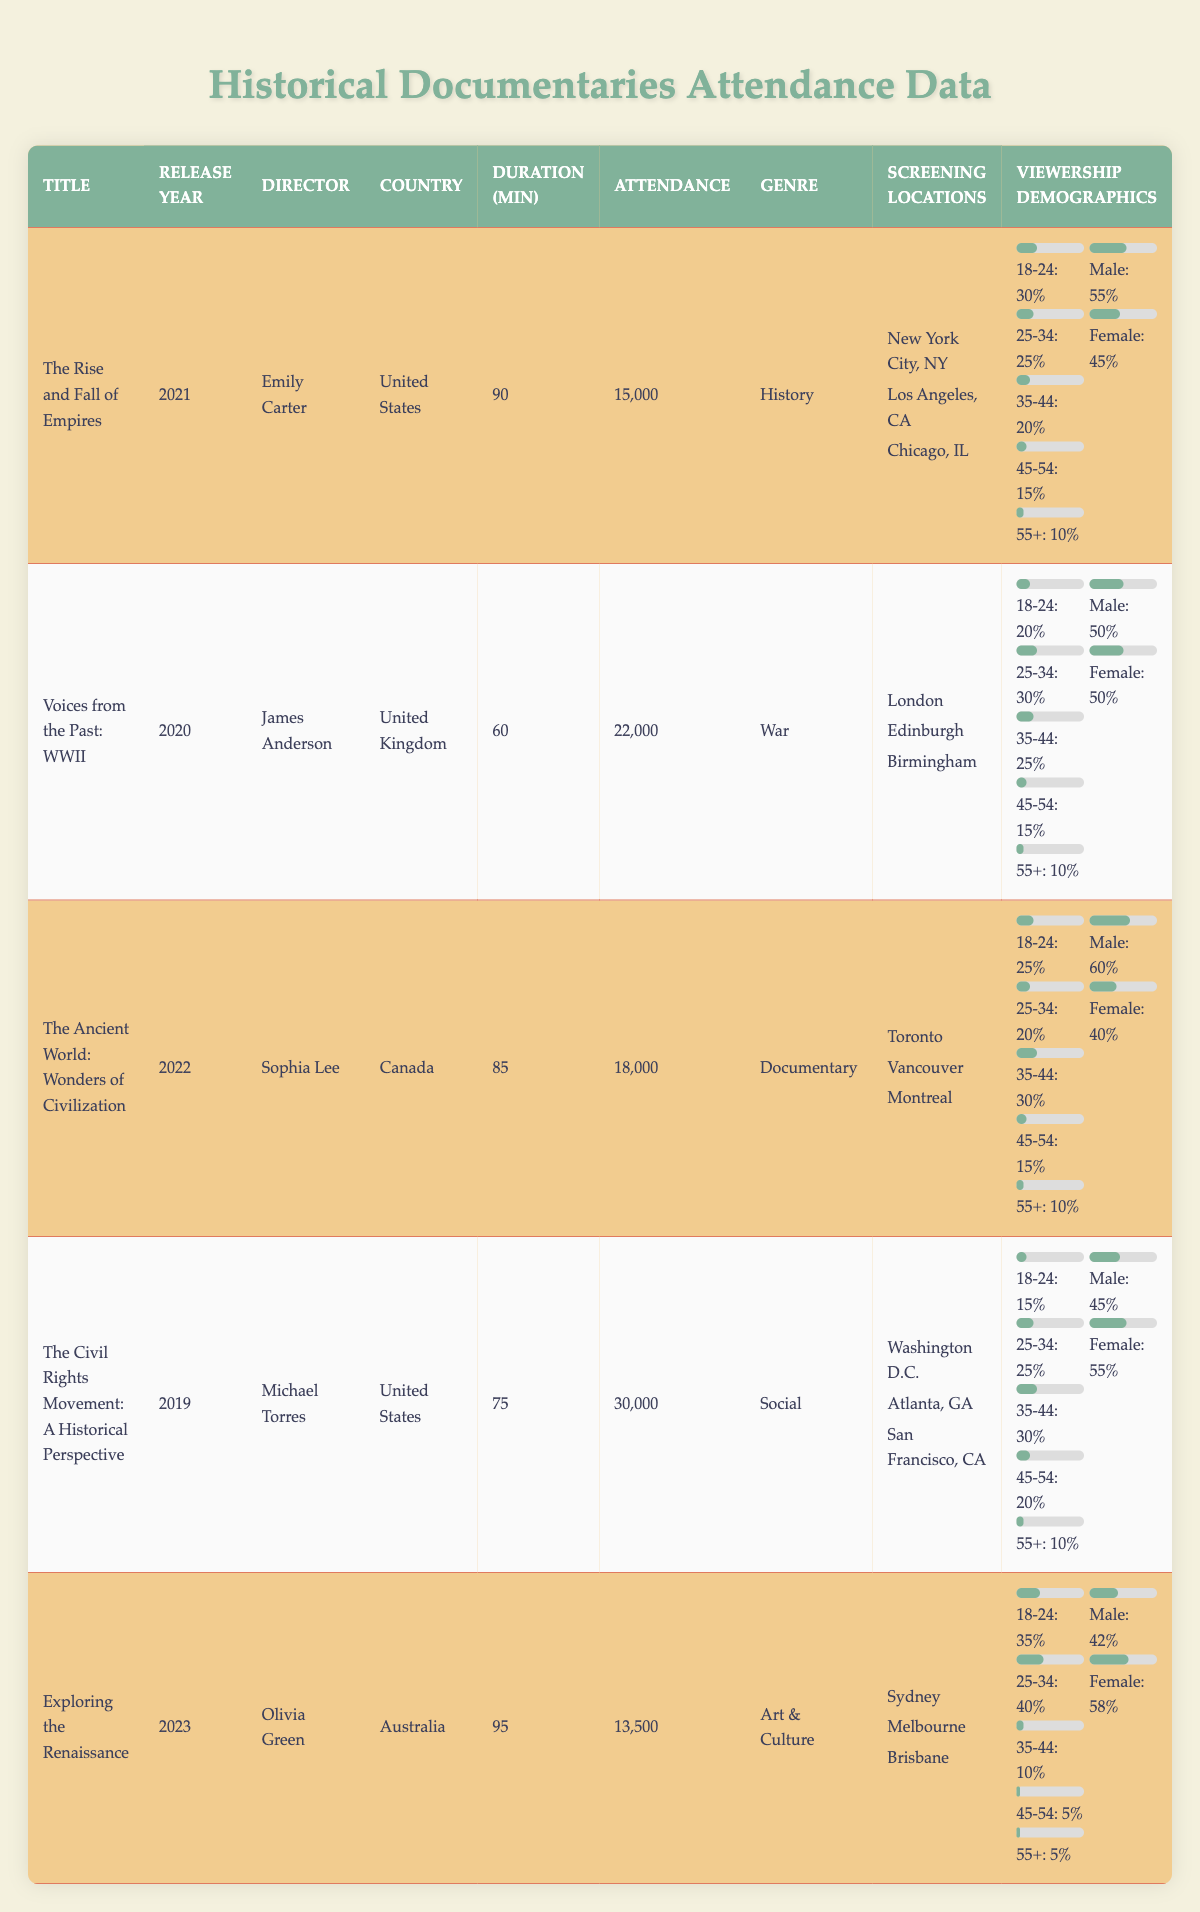What is the attendance for "The Civil Rights Movement: A Historical Perspective"? The attendance value is found directly in the table under the corresponding title. It states that "The Civil Rights Movement: A Historical Perspective" has an attendance of 30,000.
Answer: 30,000 Which historical documentary has the highest attendance? By comparing the attendance figures in the attendance column, "The Civil Rights Movement: A Historical Perspective" has the highest attendance of 30,000, compared to the others.
Answer: The Civil Rights Movement: A Historical Perspective How many minutes long is "Exploring the Renaissance"? The duration for "Exploring the Renaissance" is given directly in the table under the duration column, which states it's 95 minutes long.
Answer: 95 minutes In which country was "The Ancient World: Wonders of Civilization" directed? The table explicitly states that "The Ancient World: Wonders of Civilization" was directed in Canada, which is indicated in the country column.
Answer: Canada What is the age group percentage for the demographic of 35-44 for the documentary "Voices from the Past: WWII"? The age group demographic percentage for 35-44 is listed in the table under the viewership demographics section for that documentary, showing it is 25%.
Answer: 25% What are the total attendance figures for the documentaries screened in the United States? The total attendance figures for U.S. documentaries are calculated by summing the attendance: 15,000 (The Rise and Fall of Empires) + 30,000 (The Civil Rights Movement: A Historical Perspective) = 45,000.
Answer: 45,000 Is "Exploring the Renaissance" the only documentary directed by a female director? In the table, Olivia Green is listed as the director of "Exploring the Renaissance". However, another documentary, "The Rise and Fall of Empires", also has a female director (Emily Carter). Since there are at least two female-directed documentaries, the answer is no.
Answer: No Which documentary has the shortest duration and what is that duration? The duration column reveals that "Voices from the Past: WWII" is the shortest at 60 minutes, as it has the least time listed when compared to others.
Answer: 60 minutes What is the combined attendance for the documentaries released in 2022 and 2023? The documentaries released in 2022 and 2023 are "The Ancient World: Wonders of Civilization" (18,000) and "Exploring the Renaissance" (13,500). Adding these values gives 18,000 + 13,500 = 31,500.
Answer: 31,500 What percentage of attendees for "The Rise and Fall of Empires" were female? In the demographics for "The Rise and Fall of Empires," it is stated that 45% of the attendees were female, which can be found in the gender section.
Answer: 45% What is the most popular demographic age group for "Exploring the Renaissance"? The table shows that the age group with the highest percentage for "Exploring the Renaissance" is 25-34, with 40%, indicated by the age demographics data.
Answer: 25-34 What country had the highest male demographic percentage among the documentaries listed? By reviewing the gender demographics, "The Ancient World: Wonders of Civilization" shows the highest male demographic at 60% compared to others.
Answer: Canada 